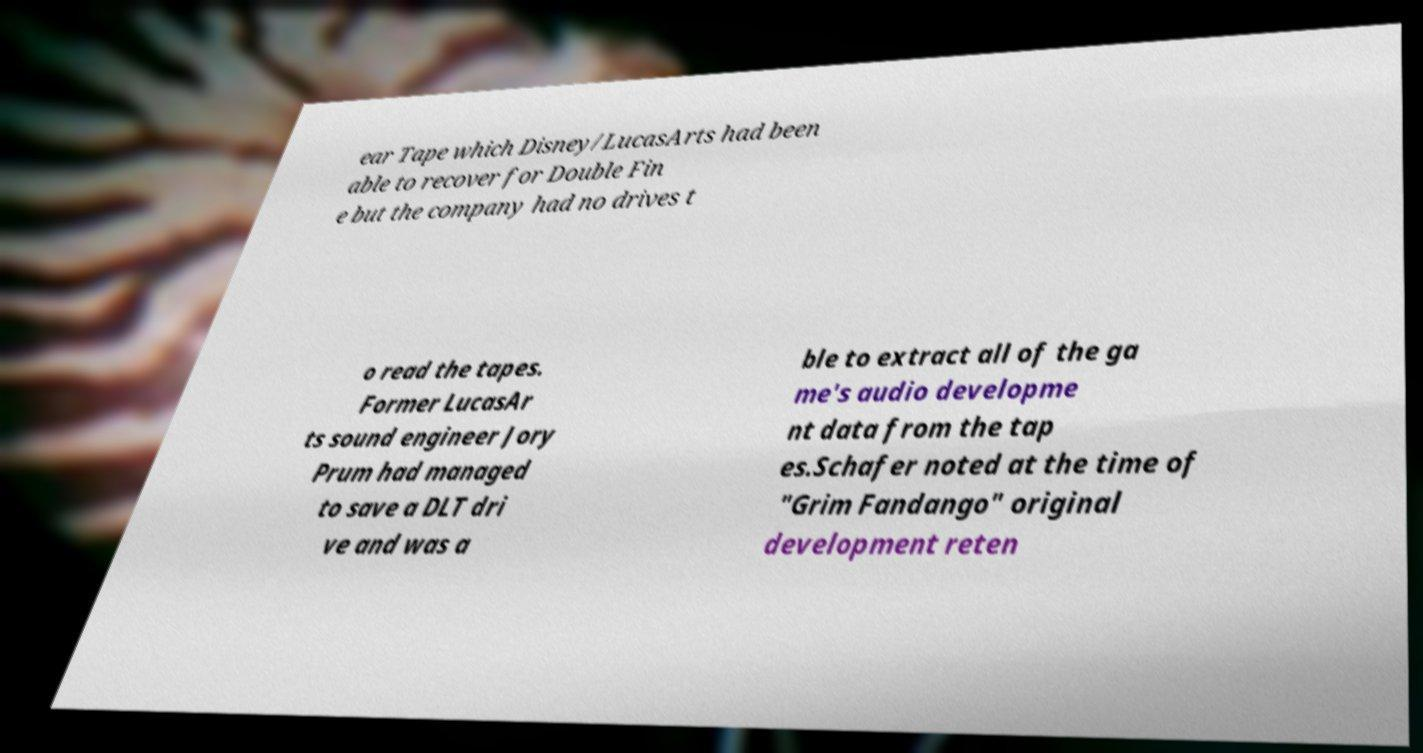For documentation purposes, I need the text within this image transcribed. Could you provide that? ear Tape which Disney/LucasArts had been able to recover for Double Fin e but the company had no drives t o read the tapes. Former LucasAr ts sound engineer Jory Prum had managed to save a DLT dri ve and was a ble to extract all of the ga me's audio developme nt data from the tap es.Schafer noted at the time of "Grim Fandango" original development reten 